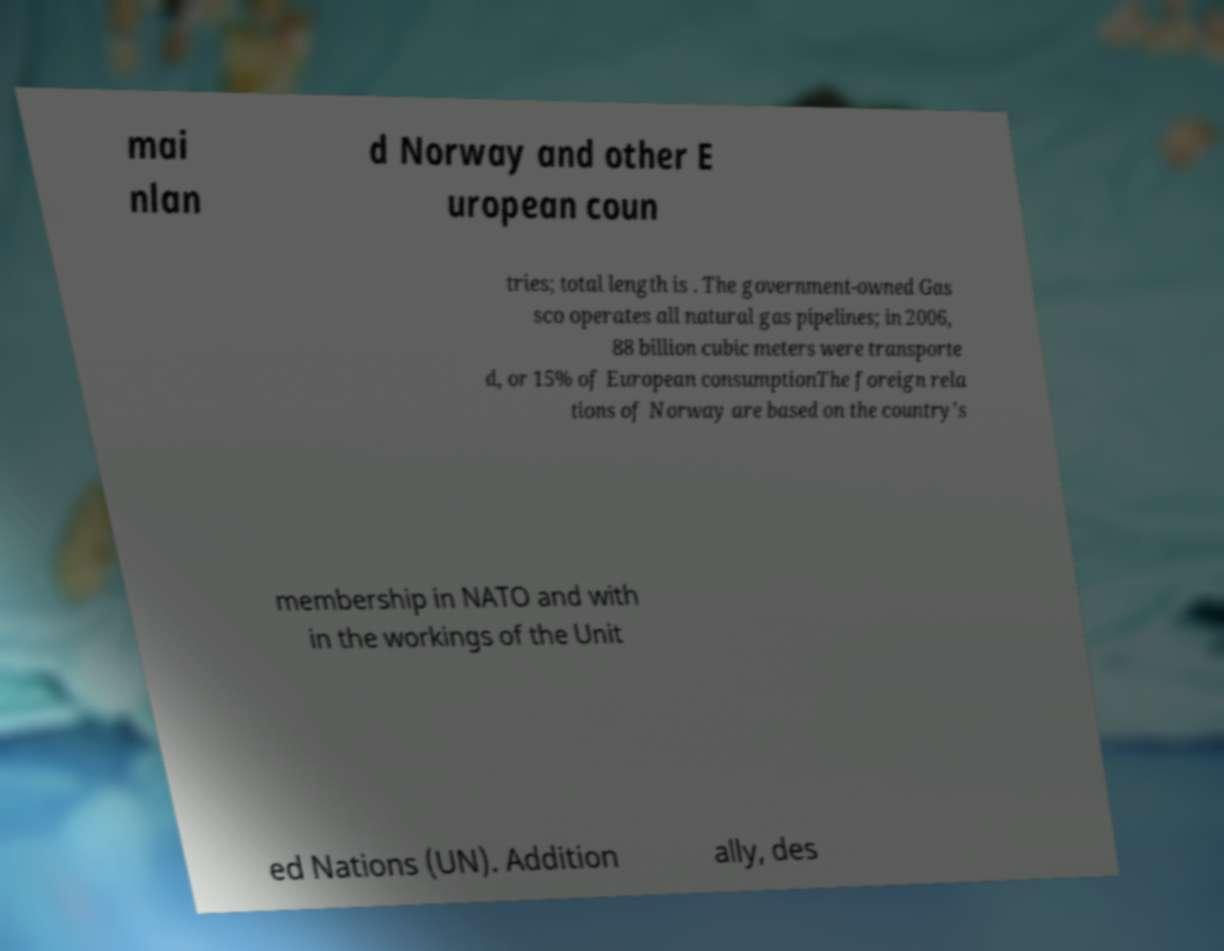There's text embedded in this image that I need extracted. Can you transcribe it verbatim? mai nlan d Norway and other E uropean coun tries; total length is . The government-owned Gas sco operates all natural gas pipelines; in 2006, 88 billion cubic meters were transporte d, or 15% of European consumptionThe foreign rela tions of Norway are based on the country's membership in NATO and with in the workings of the Unit ed Nations (UN). Addition ally, des 